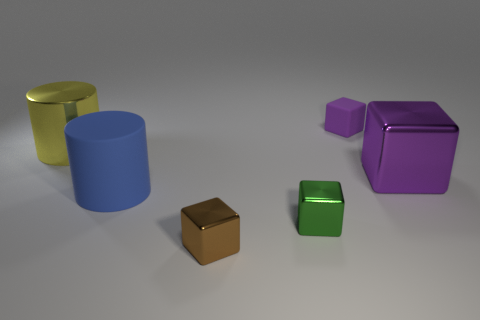Subtract 1 cubes. How many cubes are left? 3 Add 3 tiny brown things. How many objects exist? 9 Subtract all blue cubes. Subtract all green cylinders. How many cubes are left? 4 Subtract all cubes. How many objects are left? 2 Add 6 green metallic cubes. How many green metallic cubes exist? 7 Subtract 0 blue balls. How many objects are left? 6 Subtract all large balls. Subtract all big yellow shiny cylinders. How many objects are left? 5 Add 6 brown metallic things. How many brown metallic things are left? 7 